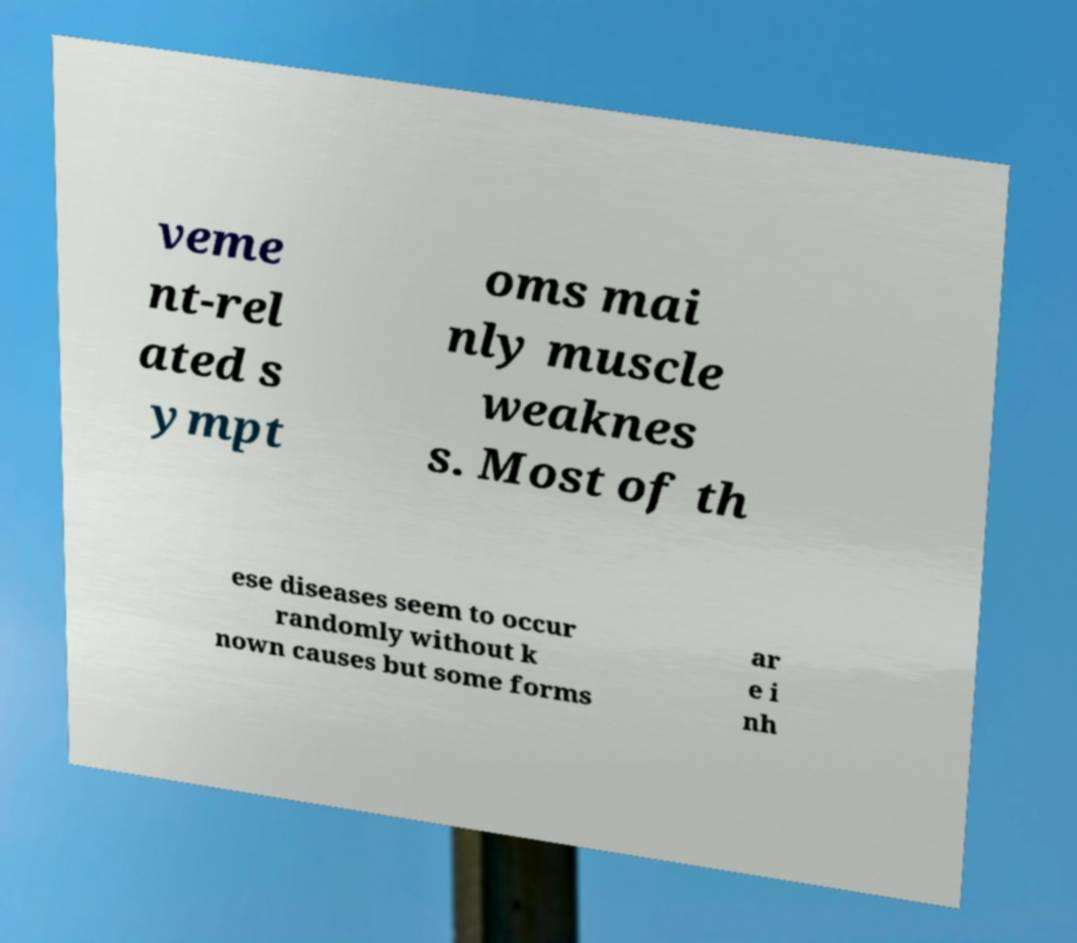I need the written content from this picture converted into text. Can you do that? veme nt-rel ated s ympt oms mai nly muscle weaknes s. Most of th ese diseases seem to occur randomly without k nown causes but some forms ar e i nh 